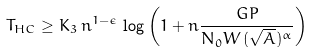Convert formula to latex. <formula><loc_0><loc_0><loc_500><loc_500>T _ { H C } \geq K _ { 3 } \, n ^ { 1 - \epsilon } \, \log \left ( 1 + n \frac { G P } { N _ { 0 } W \, ( \sqrt { A } ) ^ { \alpha } } \right )</formula> 